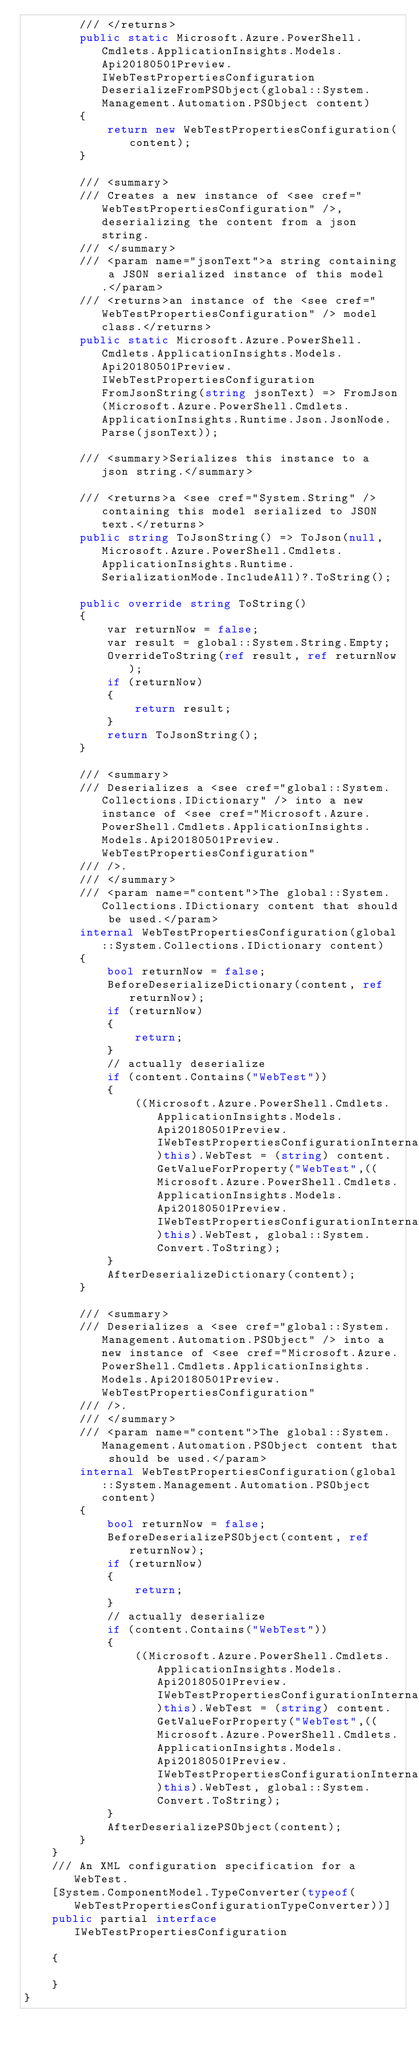<code> <loc_0><loc_0><loc_500><loc_500><_C#_>        /// </returns>
        public static Microsoft.Azure.PowerShell.Cmdlets.ApplicationInsights.Models.Api20180501Preview.IWebTestPropertiesConfiguration DeserializeFromPSObject(global::System.Management.Automation.PSObject content)
        {
            return new WebTestPropertiesConfiguration(content);
        }

        /// <summary>
        /// Creates a new instance of <see cref="WebTestPropertiesConfiguration" />, deserializing the content from a json string.
        /// </summary>
        /// <param name="jsonText">a string containing a JSON serialized instance of this model.</param>
        /// <returns>an instance of the <see cref="WebTestPropertiesConfiguration" /> model class.</returns>
        public static Microsoft.Azure.PowerShell.Cmdlets.ApplicationInsights.Models.Api20180501Preview.IWebTestPropertiesConfiguration FromJsonString(string jsonText) => FromJson(Microsoft.Azure.PowerShell.Cmdlets.ApplicationInsights.Runtime.Json.JsonNode.Parse(jsonText));

        /// <summary>Serializes this instance to a json string.</summary>

        /// <returns>a <see cref="System.String" /> containing this model serialized to JSON text.</returns>
        public string ToJsonString() => ToJson(null, Microsoft.Azure.PowerShell.Cmdlets.ApplicationInsights.Runtime.SerializationMode.IncludeAll)?.ToString();

        public override string ToString()
        {
            var returnNow = false;
            var result = global::System.String.Empty;
            OverrideToString(ref result, ref returnNow);
            if (returnNow)
            {
                return result;
            }
            return ToJsonString();
        }

        /// <summary>
        /// Deserializes a <see cref="global::System.Collections.IDictionary" /> into a new instance of <see cref="Microsoft.Azure.PowerShell.Cmdlets.ApplicationInsights.Models.Api20180501Preview.WebTestPropertiesConfiguration"
        /// />.
        /// </summary>
        /// <param name="content">The global::System.Collections.IDictionary content that should be used.</param>
        internal WebTestPropertiesConfiguration(global::System.Collections.IDictionary content)
        {
            bool returnNow = false;
            BeforeDeserializeDictionary(content, ref returnNow);
            if (returnNow)
            {
                return;
            }
            // actually deserialize
            if (content.Contains("WebTest"))
            {
                ((Microsoft.Azure.PowerShell.Cmdlets.ApplicationInsights.Models.Api20180501Preview.IWebTestPropertiesConfigurationInternal)this).WebTest = (string) content.GetValueForProperty("WebTest",((Microsoft.Azure.PowerShell.Cmdlets.ApplicationInsights.Models.Api20180501Preview.IWebTestPropertiesConfigurationInternal)this).WebTest, global::System.Convert.ToString);
            }
            AfterDeserializeDictionary(content);
        }

        /// <summary>
        /// Deserializes a <see cref="global::System.Management.Automation.PSObject" /> into a new instance of <see cref="Microsoft.Azure.PowerShell.Cmdlets.ApplicationInsights.Models.Api20180501Preview.WebTestPropertiesConfiguration"
        /// />.
        /// </summary>
        /// <param name="content">The global::System.Management.Automation.PSObject content that should be used.</param>
        internal WebTestPropertiesConfiguration(global::System.Management.Automation.PSObject content)
        {
            bool returnNow = false;
            BeforeDeserializePSObject(content, ref returnNow);
            if (returnNow)
            {
                return;
            }
            // actually deserialize
            if (content.Contains("WebTest"))
            {
                ((Microsoft.Azure.PowerShell.Cmdlets.ApplicationInsights.Models.Api20180501Preview.IWebTestPropertiesConfigurationInternal)this).WebTest = (string) content.GetValueForProperty("WebTest",((Microsoft.Azure.PowerShell.Cmdlets.ApplicationInsights.Models.Api20180501Preview.IWebTestPropertiesConfigurationInternal)this).WebTest, global::System.Convert.ToString);
            }
            AfterDeserializePSObject(content);
        }
    }
    /// An XML configuration specification for a WebTest.
    [System.ComponentModel.TypeConverter(typeof(WebTestPropertiesConfigurationTypeConverter))]
    public partial interface IWebTestPropertiesConfiguration

    {

    }
}</code> 